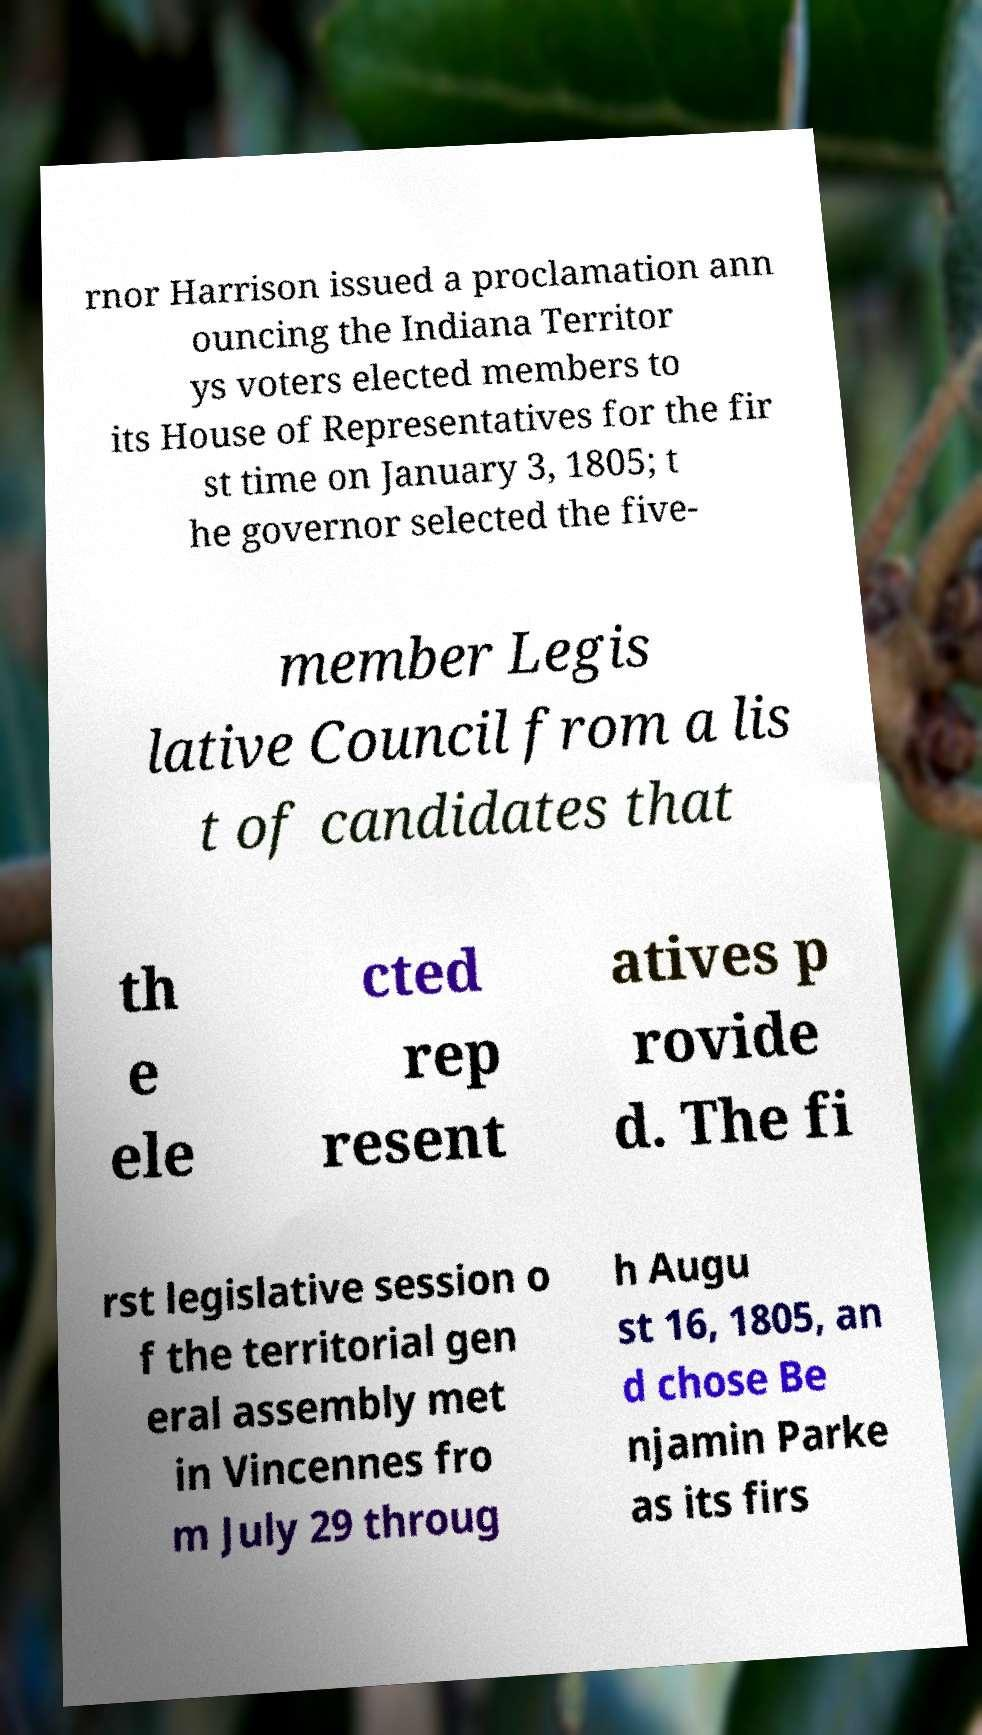Could you extract and type out the text from this image? rnor Harrison issued a proclamation ann ouncing the Indiana Territor ys voters elected members to its House of Representatives for the fir st time on January 3, 1805; t he governor selected the five- member Legis lative Council from a lis t of candidates that th e ele cted rep resent atives p rovide d. The fi rst legislative session o f the territorial gen eral assembly met in Vincennes fro m July 29 throug h Augu st 16, 1805, an d chose Be njamin Parke as its firs 